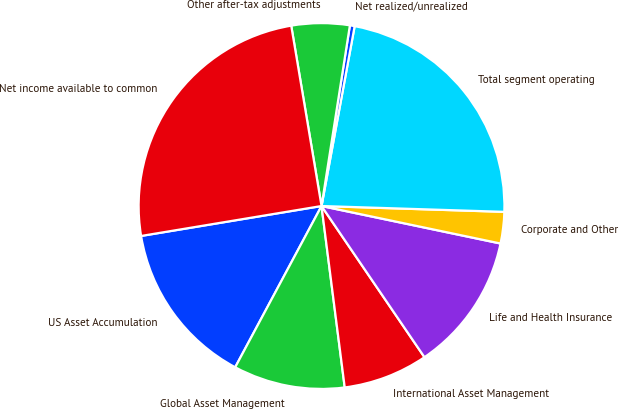<chart> <loc_0><loc_0><loc_500><loc_500><pie_chart><fcel>US Asset Accumulation<fcel>Global Asset Management<fcel>International Asset Management<fcel>Life and Health Insurance<fcel>Corporate and Other<fcel>Total segment operating<fcel>Net realized/unrealized<fcel>Other after-tax adjustments<fcel>Net income available to common<nl><fcel>14.56%<fcel>9.85%<fcel>7.49%<fcel>12.2%<fcel>2.78%<fcel>22.61%<fcel>0.42%<fcel>5.13%<fcel>24.97%<nl></chart> 